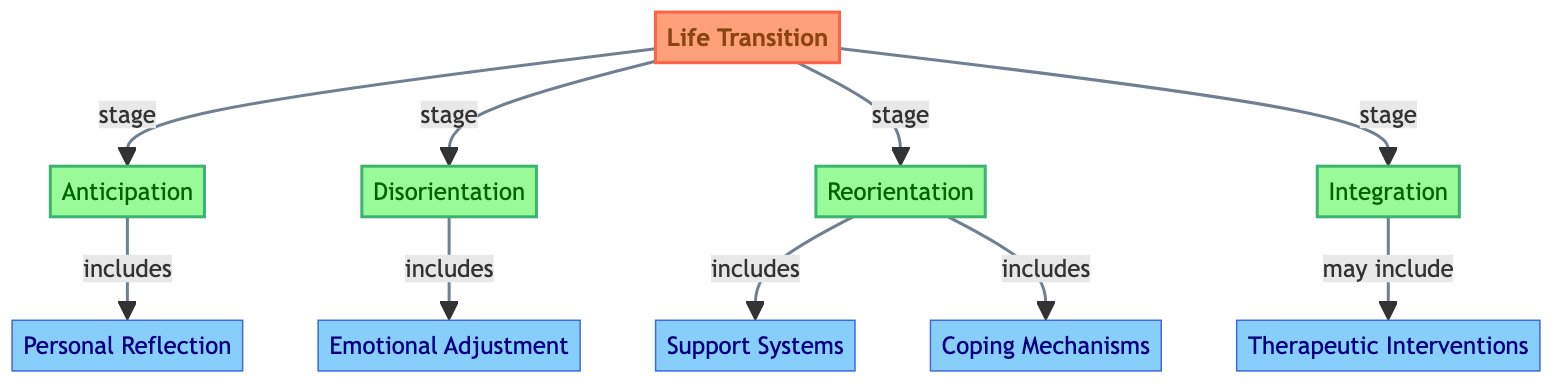What are the four stages of Life Transitions? The diagram clearly lists the four stages connected to the main topic "Life Transition". They are: Anticipation, Disorientation, Reorientation, and Integration.
Answer: Anticipation, Disorientation, Reorientation, Integration Which stage includes Personal Reflection? The stage "Anticipation" is linked to "Personal Reflection" in the diagram with the relation "includes." Therefore, it indicates that Personal Reflection is part of the Anticipation stage.
Answer: Anticipation How many components are included under Reorientation? The diagram shows that "Reorientation" includes two components: Support Systems and Coping Mechanisms. This is determined by counting the number of connections from Reorientation to its included components.
Answer: 2 What is the relationship between Integration and Therapeutic Interventions? The diagram indicates that Therapeutic Interventions "may include" Integration, showing a non-restrictive connection, implying that while Integration may utilize Therapeutic Interventions, it is not exclusively dependent on them.
Answer: may include Which stage involves Emotional Adjustment? According to the diagram, Emotional Adjustment is connected to "Disorientation," indicating that it is a component of that particular stage.
Answer: Disorientation What type of relationship is established between each stage and Life Transition? The relationship between each stage (Anticipation, Disorientation, Reorientation, Integration) and Life Transition is categorized as "stage," indicating that all are parts of the overall process of life transitions.
Answer: stage How many total components are there in the diagram? The diagram lists five components: Personal Reflection, Emotional Adjustment, Support Systems, Coping Mechanisms, and Therapeutic Interventions. Adding these together gives the total number of components.
Answer: 5 Which stage includes both Support Systems and Coping Mechanisms? The stage "Reorientation" is shown to include both Support Systems and Coping Mechanisms, as stated in the connections of the diagram.
Answer: Reorientation 